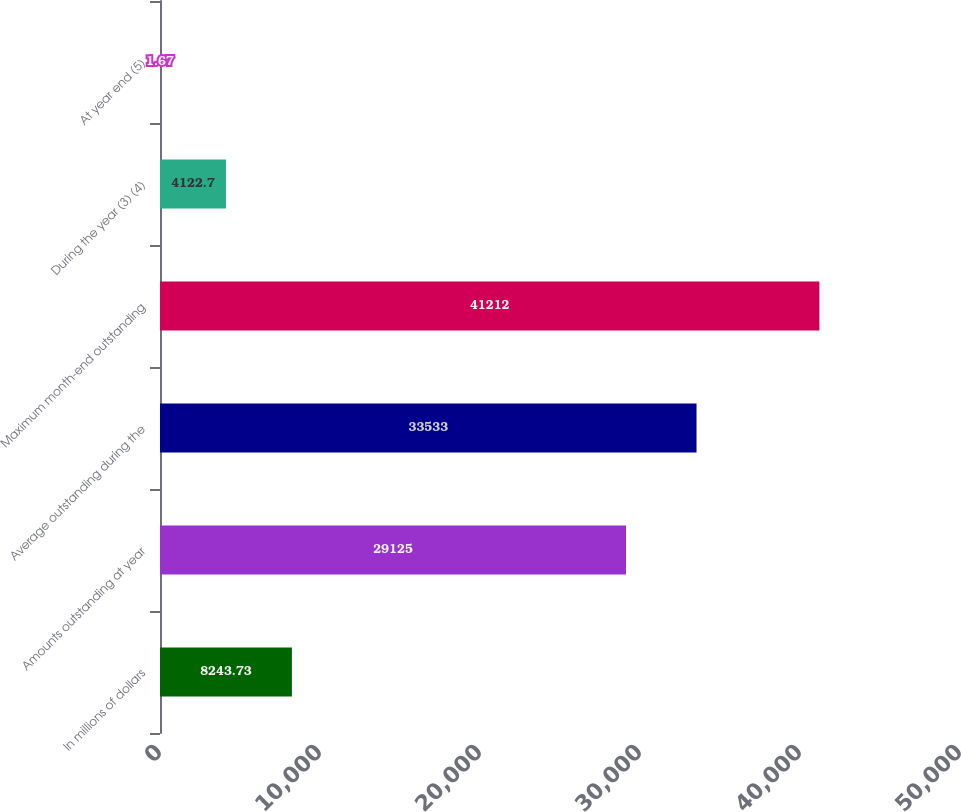Convert chart. <chart><loc_0><loc_0><loc_500><loc_500><bar_chart><fcel>In millions of dollars<fcel>Amounts outstanding at year<fcel>Average outstanding during the<fcel>Maximum month-end outstanding<fcel>During the year (3) (4)<fcel>At year end (5)<nl><fcel>8243.73<fcel>29125<fcel>33533<fcel>41212<fcel>4122.7<fcel>1.67<nl></chart> 